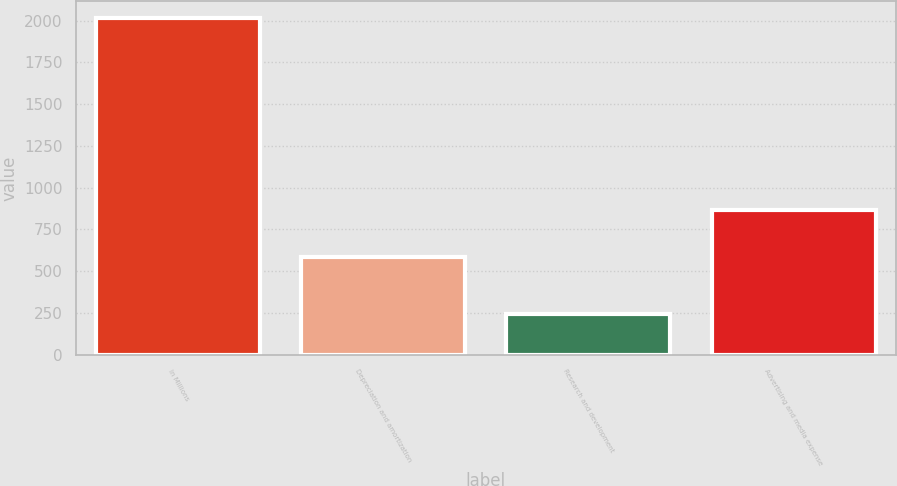<chart> <loc_0><loc_0><loc_500><loc_500><bar_chart><fcel>In Millions<fcel>Depreciation and amortization<fcel>Research and development<fcel>Advertising and media expense<nl><fcel>2014<fcel>585.4<fcel>243.6<fcel>869.5<nl></chart> 